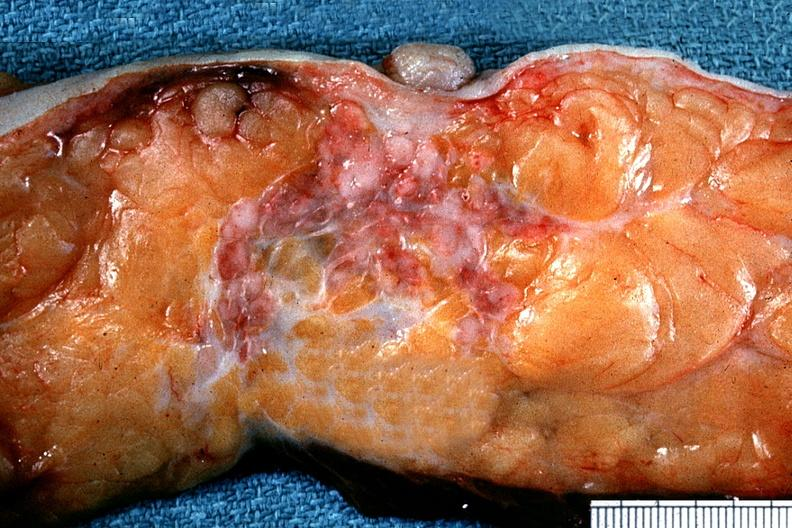does metastatic carcinoma prostate show excellent example of carcinoma below nipple in cross section?
Answer the question using a single word or phrase. No 